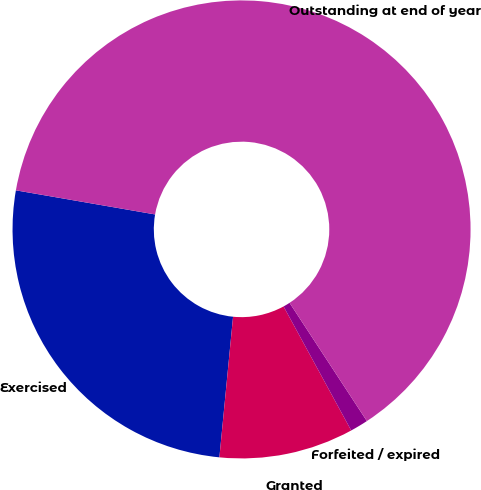<chart> <loc_0><loc_0><loc_500><loc_500><pie_chart><fcel>Exercised<fcel>Granted<fcel>Forfeited / expired<fcel>Outstanding at end of year<nl><fcel>26.19%<fcel>9.49%<fcel>1.27%<fcel>63.06%<nl></chart> 